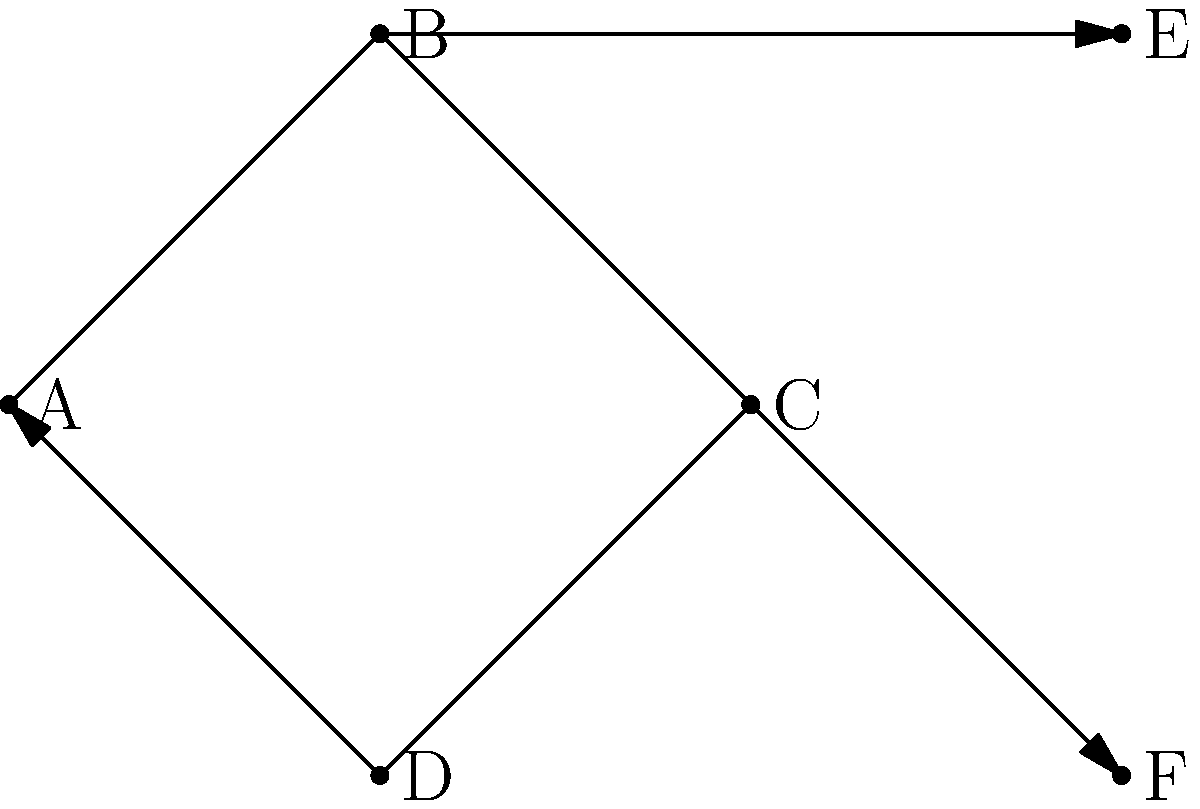In the context of modeling the spread of historical empires using group theory-based network diagrams, consider the graph above representing the expansion of an empire. Nodes represent territories, and directed edges represent the order of conquest. If we define a group operation where the composition of two conquests is represented by following their paths, what is the order of the subgroup generated by the cycle A → B → C → D → A? To determine the order of the subgroup generated by the cycle A → B → C → D → A, we need to follow these steps:

1. Identify the cycle: The cycle is A → B → C → D → A.

2. Understand the group operation: The composition of conquests is represented by following their paths.

3. Determine the elements of the subgroup:
   - Identity element: No movement (staying in the same territory)
   - One rotation: A → B → C → D → A
   - Two rotations: A → C → A → B → D
   - Three rotations: A → D → B → C → A

4. Count the number of unique elements:
   - Identity
   - One full rotation
   - Two rotations
   - Three rotations

5. Observe that four rotations bring us back to the identity element.

Therefore, the subgroup generated by this cycle has 4 elements, corresponding to the number of territories in the cycle.

In group theory terms, this subgroup is isomorphic to the cyclic group of order 4, denoted as $C_4$ or $\mathbb{Z}/4\mathbb{Z}$.
Answer: 4 